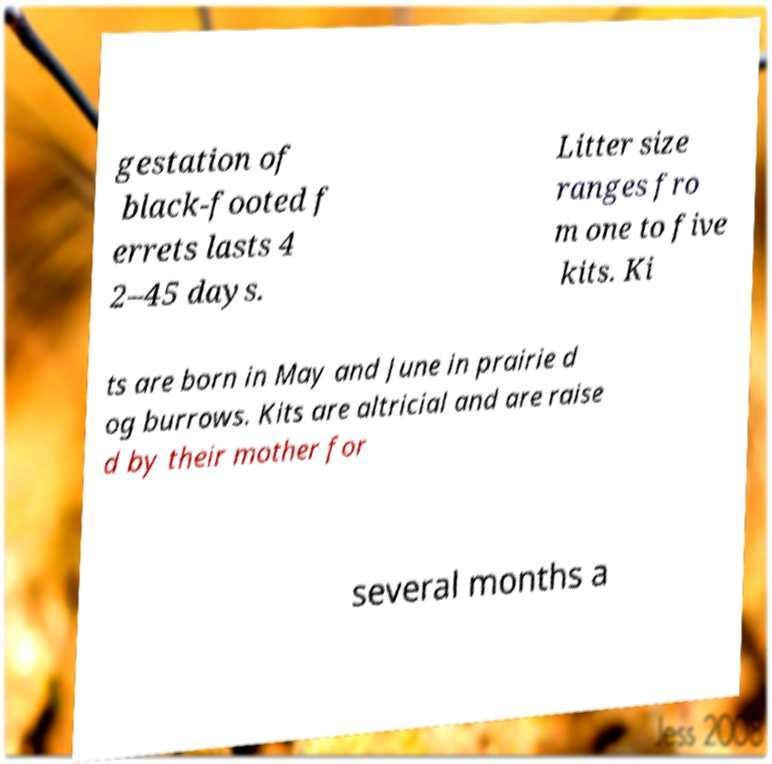There's text embedded in this image that I need extracted. Can you transcribe it verbatim? gestation of black-footed f errets lasts 4 2–45 days. Litter size ranges fro m one to five kits. Ki ts are born in May and June in prairie d og burrows. Kits are altricial and are raise d by their mother for several months a 